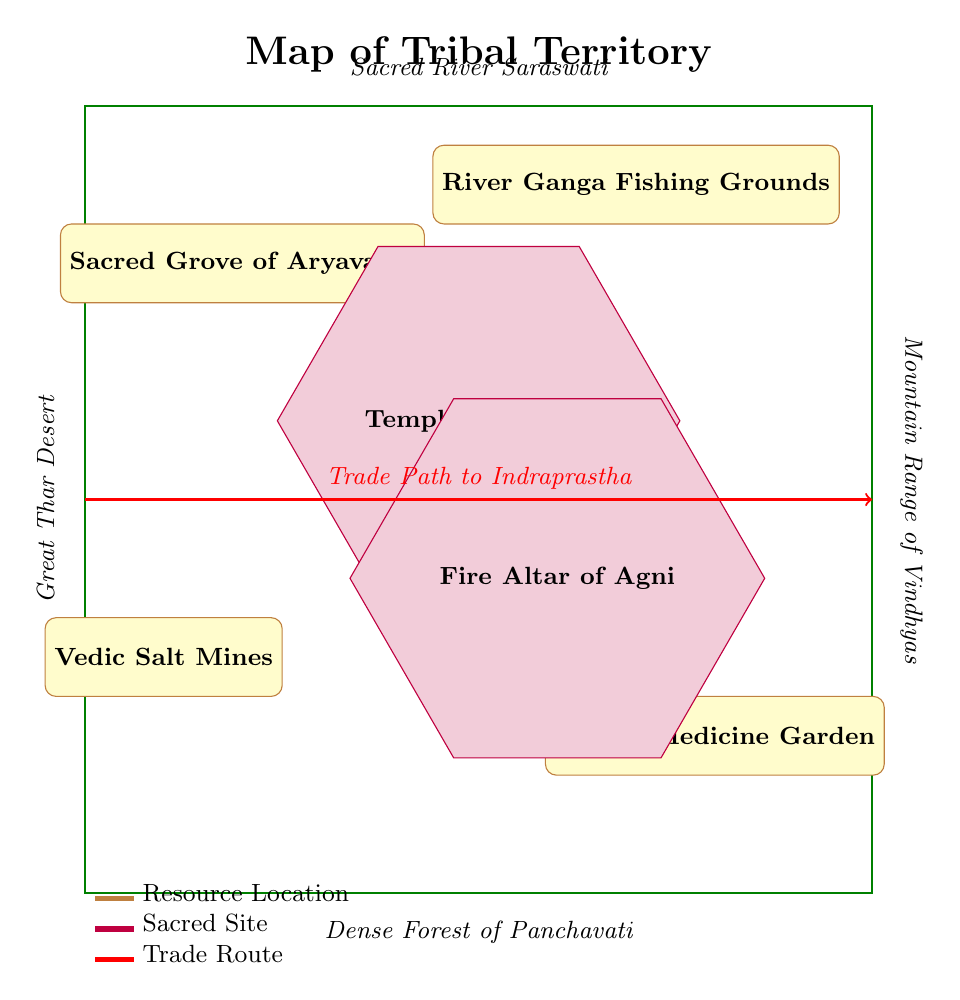What is the name of the sacred site located at (0,1)? The sacred site at the coordinates (0,1) is labeled as "Temple of Mithra" in the diagram.
Answer: Temple of Mithra How many resource locations are present in the tribal territory? By counting the labeled nodes designated as resources in the diagram, there are four resources: Sacred Grove of Aryavarta, River Ganga Fishing Grounds, Vedic Salt Mines, and Herbal Medicine Garden.
Answer: 4 What is the trade route direction indicated in the diagram? The trade route is represented by a red arrow that moves horizontally from the left (-5,0) to the right (5,0), indicating it runs east-west across the territory.
Answer: East-West What type of natural boundary is indicated to the north of the territory? The northern boundary is marked by the "Sacred River Saraswati," representing a significant natural feature of the landscape in that direction.
Answer: Sacred River Saraswati Which resource is shown in the south-western part of the territory? The diagram shows the "Vedic Salt Mines" located in the south-west area of the tribal territory, specifically at the coordinates (-4,-2).
Answer: Vedic Salt Mines If the Temple of Mithra and the Fire Altar of Agni were connected by a trade route, what would be the approximate direction from the temple to the altar? To analyze the relative positions, "Temple of Mithra" (0,1) is located to the north-east of the "Fire Altar of Agni" (1,-1). A trade route connecting these would generally move south-west.
Answer: South-West How many sacred sites are present in the diagram? There are two sacred sites shown in the diagram: the Temple of Mithra and the Fire Altar of Agni, as indicated by nodes marked with the sacred site style.
Answer: 2 What significant geographical feature borders the territory to the east? According to the labels in the diagram, the eastern border is noted as the "Mountain Range of Vindhyas," indicating a major geographic landmark in that direction.
Answer: Mountain Range of Vindhyas What is the purpose of the red arrow crossing the territory? The red arrow labeled "Trade Path to Indraprastha" signifies a route for trade transportation across the tribal territory, connecting resources and sites to the neighboring areas.
Answer: Trade path 